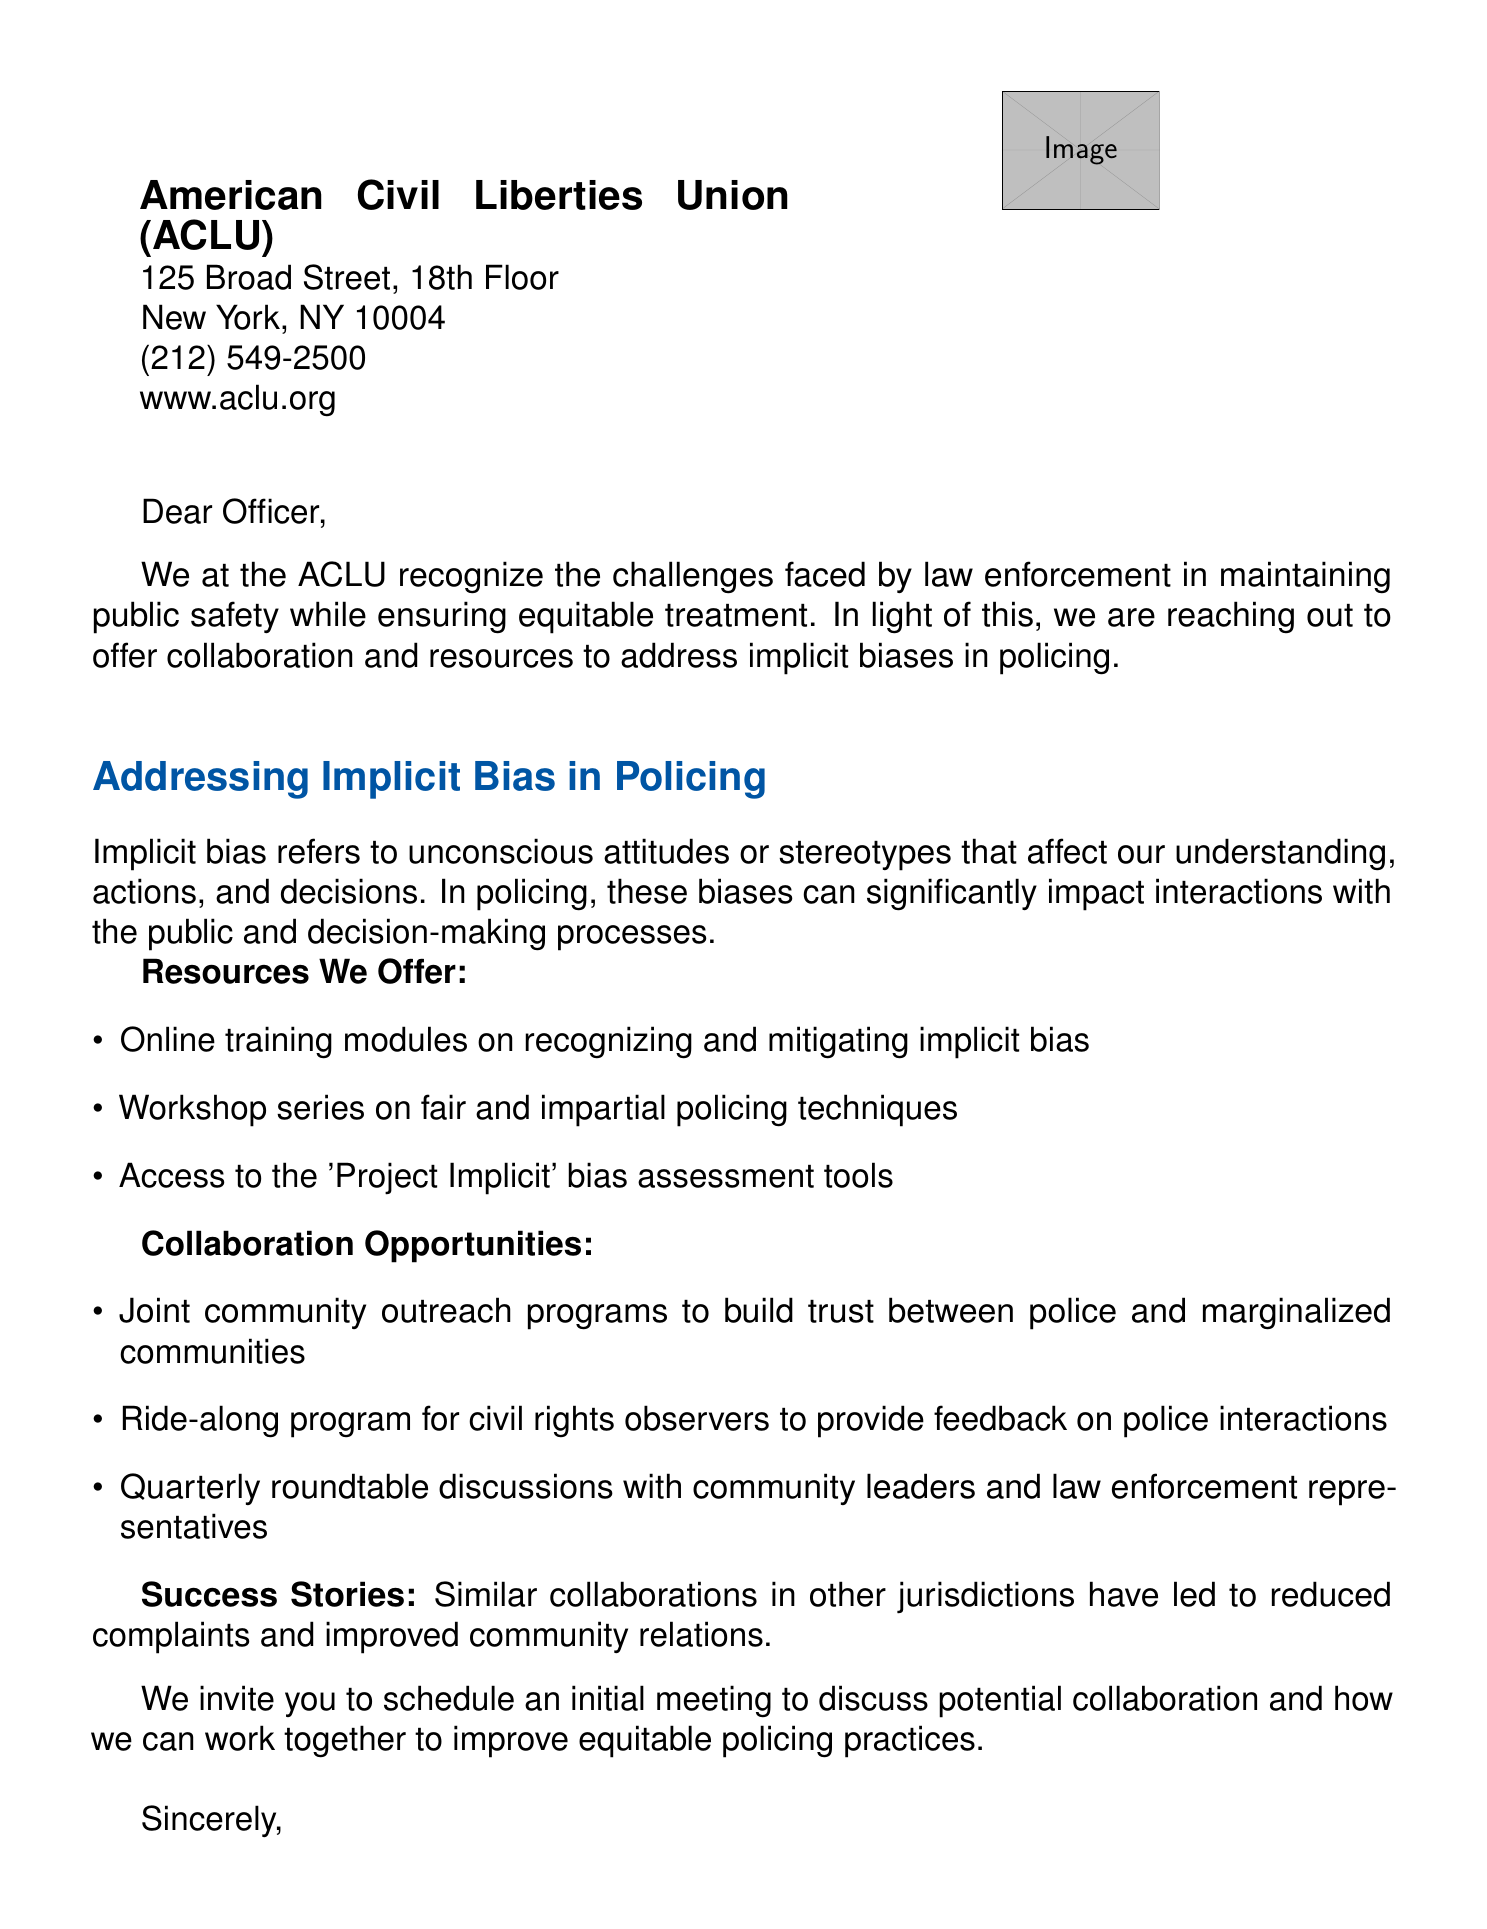What is the name of the organization? The name of the organization is mentioned in the letterhead of the document.
Answer: American Civil Liberties Union (ACLU) What is the address of the ACLU? The address is provided in the letterhead section of the document.
Answer: 125 Broad Street, 18th Floor, New York, NY 10004 What is the phone number provided by the ACLU? The phone number is listed in the letterhead of the document.
Answer: (212) 549-2500 What training resources are offered by the ACLU? The body section lists various resources, including training programs.
Answer: Online training modules on recognizing and mitigating implicit bias What is one collaboration opportunity mentioned in the letter? The letter includes multiple opportunities for collaboration.
Answer: Joint community outreach programs to build trust between police and marginalized communities Who signed the letter? The closing section identifies the person who signed the letter.
Answer: Anthony D. Romero What is the title of the person who signed the letter? The title is mentioned directly below the signature in the document.
Answer: Executive Director, ACLU What is the purpose of the letter? The introduction outlines the main reason for the letter.
Answer: Offer collaboration and resources to address implicit biases in policing What does "implicit bias" refer to in the document? The document provides a brief explanation of implicit bias in the body section.
Answer: Unconscious attitudes or stereotypes that affect understanding, actions, and decisions 